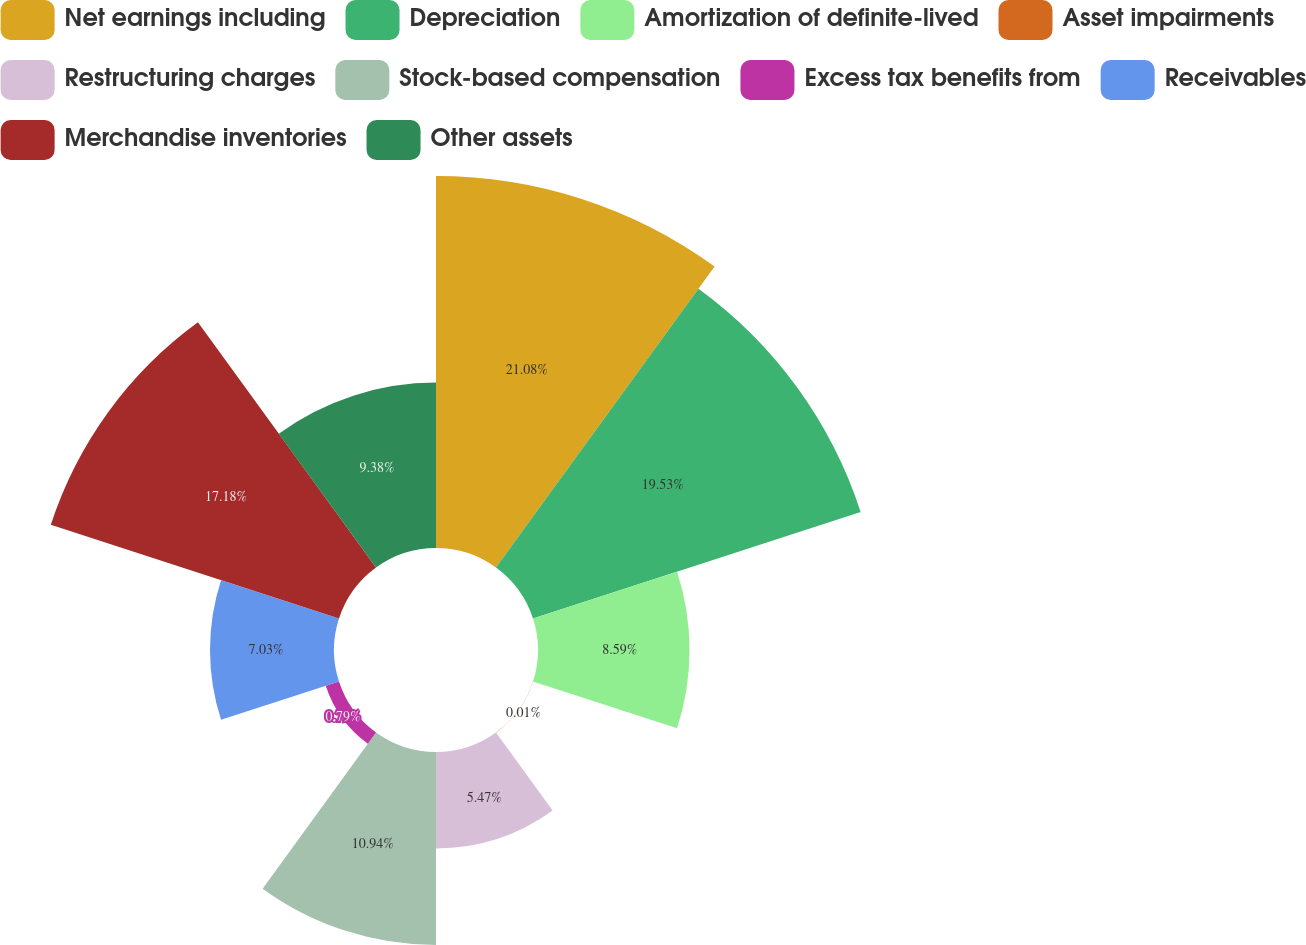Convert chart to OTSL. <chart><loc_0><loc_0><loc_500><loc_500><pie_chart><fcel>Net earnings including<fcel>Depreciation<fcel>Amortization of definite-lived<fcel>Asset impairments<fcel>Restructuring charges<fcel>Stock-based compensation<fcel>Excess tax benefits from<fcel>Receivables<fcel>Merchandise inventories<fcel>Other assets<nl><fcel>21.09%<fcel>19.53%<fcel>8.59%<fcel>0.01%<fcel>5.47%<fcel>10.94%<fcel>0.79%<fcel>7.03%<fcel>17.18%<fcel>9.38%<nl></chart> 